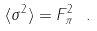Convert formula to latex. <formula><loc_0><loc_0><loc_500><loc_500>\langle \sigma ^ { 2 } \rangle = F _ { \pi } ^ { 2 } \ .</formula> 